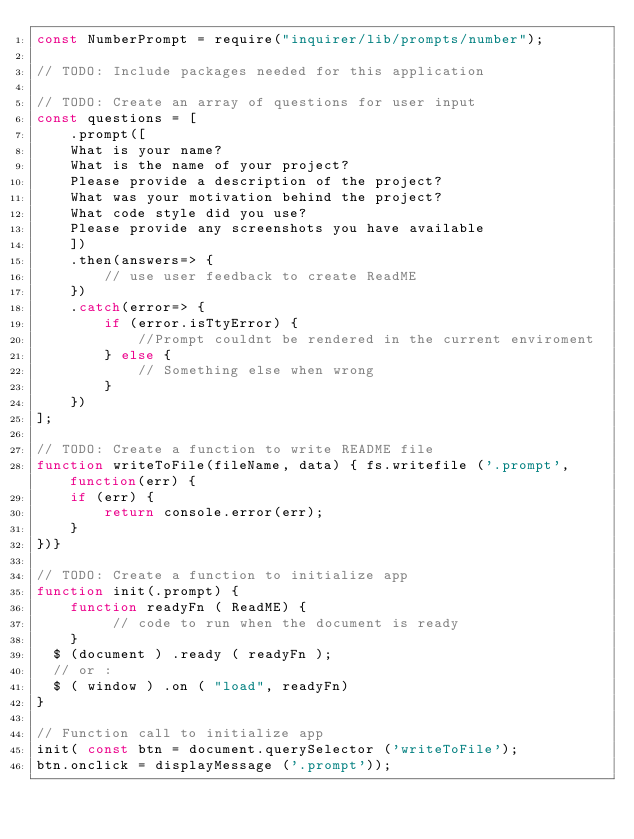Convert code to text. <code><loc_0><loc_0><loc_500><loc_500><_JavaScript_>const NumberPrompt = require("inquirer/lib/prompts/number");

// TODO: Include packages needed for this application

// TODO: Create an array of questions for user input
const questions = [
    .prompt([
    What is your name?
    What is the name of your project?
    Please provide a description of the project? 
    What was your motivation behind the project?
    What code style did you use?
    Please provide any screenshots you have available
    ])
    .then(answers=> {
        // use user feedback to create ReadME
    })
    .catch(error=> {
        if (error.isTtyError) {
            //Prompt couldnt be rendered in the current enviroment
        } else {
            // Something else when wrong
        }
    })
];

// TODO: Create a function to write README file
function writeToFile(fileName, data) { fs.writefile ('.prompt', function(err) {
    if (err) {
        return console.error(err);
    }
})}

// TODO: Create a function to initialize app
function init(.prompt) {
    function readyFn ( ReadME) {
         // code to run when the document is ready
    }
  $ (document ) .ready ( readyFn );
  // or :
  $ ( window ) .on ( "load", readyFn)
}

// Function call to initialize app
init( const btn = document.querySelector ('writeToFile');
btn.onclick = displayMessage ('.prompt'));
</code> 